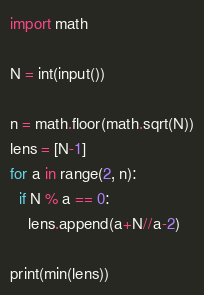Convert code to text. <code><loc_0><loc_0><loc_500><loc_500><_Python_>import math

N = int(input())

n = math.floor(math.sqrt(N))
lens = [N-1]
for a in range(2, n):
  if N % a == 0:
    lens.append(a+N//a-2)

print(min(lens))
</code> 